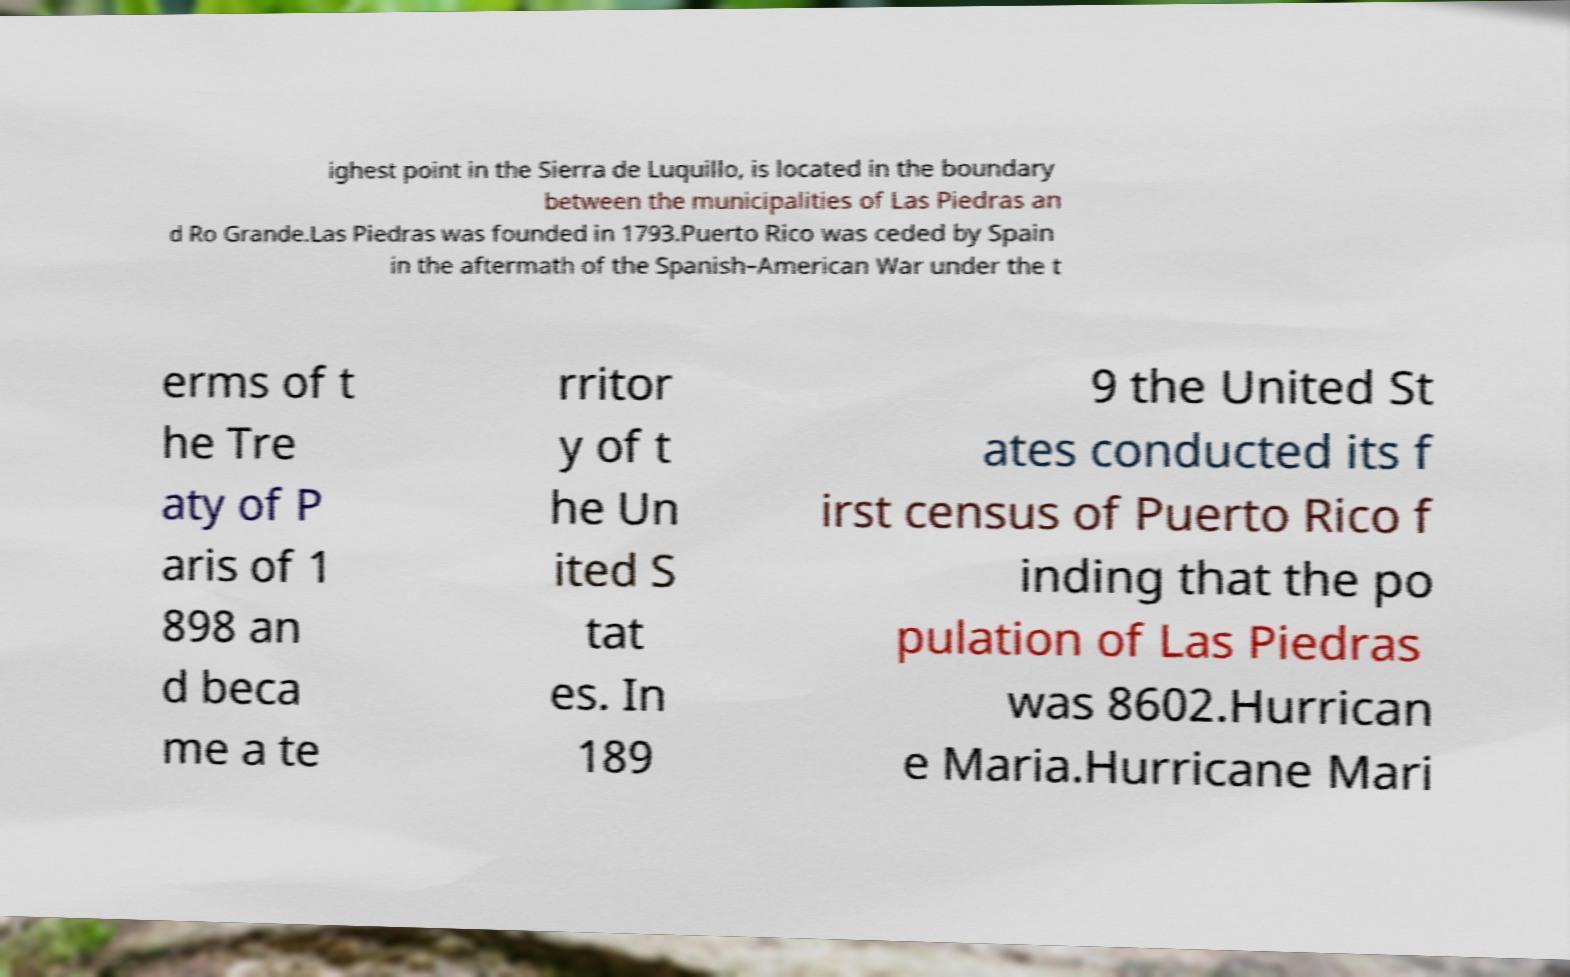Can you read and provide the text displayed in the image?This photo seems to have some interesting text. Can you extract and type it out for me? ighest point in the Sierra de Luquillo, is located in the boundary between the municipalities of Las Piedras an d Ro Grande.Las Piedras was founded in 1793.Puerto Rico was ceded by Spain in the aftermath of the Spanish–American War under the t erms of t he Tre aty of P aris of 1 898 an d beca me a te rritor y of t he Un ited S tat es. In 189 9 the United St ates conducted its f irst census of Puerto Rico f inding that the po pulation of Las Piedras was 8602.Hurrican e Maria.Hurricane Mari 